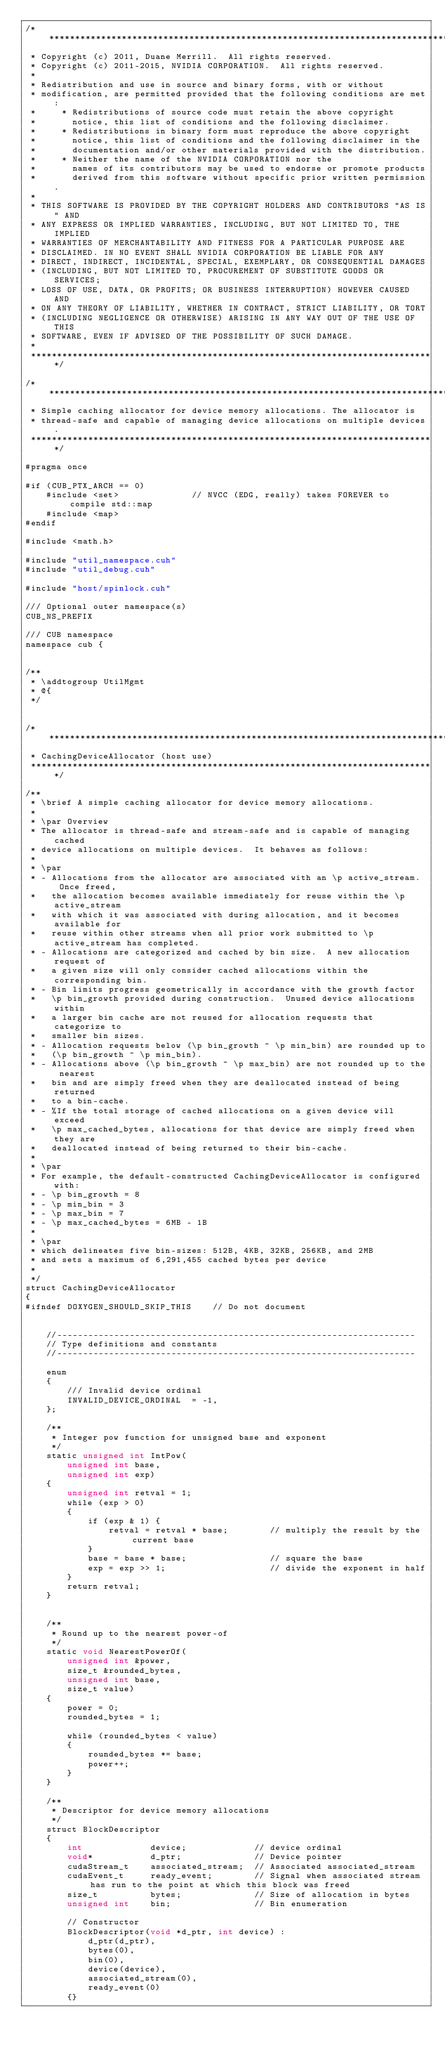Convert code to text. <code><loc_0><loc_0><loc_500><loc_500><_Cuda_>/******************************************************************************
 * Copyright (c) 2011, Duane Merrill.  All rights reserved.
 * Copyright (c) 2011-2015, NVIDIA CORPORATION.  All rights reserved.
 *
 * Redistribution and use in source and binary forms, with or without
 * modification, are permitted provided that the following conditions are met:
 *     * Redistributions of source code must retain the above copyright
 *       notice, this list of conditions and the following disclaimer.
 *     * Redistributions in binary form must reproduce the above copyright
 *       notice, this list of conditions and the following disclaimer in the
 *       documentation and/or other materials provided with the distribution.
 *     * Neither the name of the NVIDIA CORPORATION nor the
 *       names of its contributors may be used to endorse or promote products
 *       derived from this software without specific prior written permission.
 *
 * THIS SOFTWARE IS PROVIDED BY THE COPYRIGHT HOLDERS AND CONTRIBUTORS "AS IS" AND
 * ANY EXPRESS OR IMPLIED WARRANTIES, INCLUDING, BUT NOT LIMITED TO, THE IMPLIED
 * WARRANTIES OF MERCHANTABILITY AND FITNESS FOR A PARTICULAR PURPOSE ARE
 * DISCLAIMED. IN NO EVENT SHALL NVIDIA CORPORATION BE LIABLE FOR ANY
 * DIRECT, INDIRECT, INCIDENTAL, SPECIAL, EXEMPLARY, OR CONSEQUENTIAL DAMAGES
 * (INCLUDING, BUT NOT LIMITED TO, PROCUREMENT OF SUBSTITUTE GOODS OR SERVICES;
 * LOSS OF USE, DATA, OR PROFITS; OR BUSINESS INTERRUPTION) HOWEVER CAUSED AND
 * ON ANY THEORY OF LIABILITY, WHETHER IN CONTRACT, STRICT LIABILITY, OR TORT
 * (INCLUDING NEGLIGENCE OR OTHERWISE) ARISING IN ANY WAY OUT OF THE USE OF THIS
 * SOFTWARE, EVEN IF ADVISED OF THE POSSIBILITY OF SUCH DAMAGE.
 *
 ******************************************************************************/

/******************************************************************************
 * Simple caching allocator for device memory allocations. The allocator is
 * thread-safe and capable of managing device allocations on multiple devices.
 ******************************************************************************/

#pragma once

#if (CUB_PTX_ARCH == 0)
    #include <set>              // NVCC (EDG, really) takes FOREVER to compile std::map
    #include <map>
#endif

#include <math.h>

#include "util_namespace.cuh"
#include "util_debug.cuh"

#include "host/spinlock.cuh"

/// Optional outer namespace(s)
CUB_NS_PREFIX

/// CUB namespace
namespace cub {


/**
 * \addtogroup UtilMgmt
 * @{
 */


/******************************************************************************
 * CachingDeviceAllocator (host use)
 ******************************************************************************/

/**
 * \brief A simple caching allocator for device memory allocations.
 *
 * \par Overview
 * The allocator is thread-safe and stream-safe and is capable of managing cached
 * device allocations on multiple devices.  It behaves as follows:
 *
 * \par
 * - Allocations from the allocator are associated with an \p active_stream.  Once freed,
 *   the allocation becomes available immediately for reuse within the \p active_stream
 *   with which it was associated with during allocation, and it becomes available for
 *   reuse within other streams when all prior work submitted to \p active_stream has completed.
 * - Allocations are categorized and cached by bin size.  A new allocation request of
 *   a given size will only consider cached allocations within the corresponding bin.
 * - Bin limits progress geometrically in accordance with the growth factor
 *   \p bin_growth provided during construction.  Unused device allocations within
 *   a larger bin cache are not reused for allocation requests that categorize to
 *   smaller bin sizes.
 * - Allocation requests below (\p bin_growth ^ \p min_bin) are rounded up to
 *   (\p bin_growth ^ \p min_bin).
 * - Allocations above (\p bin_growth ^ \p max_bin) are not rounded up to the nearest
 *   bin and are simply freed when they are deallocated instead of being returned
 *   to a bin-cache.
 * - %If the total storage of cached allocations on a given device will exceed
 *   \p max_cached_bytes, allocations for that device are simply freed when they are
 *   deallocated instead of being returned to their bin-cache.
 *
 * \par
 * For example, the default-constructed CachingDeviceAllocator is configured with:
 * - \p bin_growth = 8
 * - \p min_bin = 3
 * - \p max_bin = 7
 * - \p max_cached_bytes = 6MB - 1B
 *
 * \par
 * which delineates five bin-sizes: 512B, 4KB, 32KB, 256KB, and 2MB
 * and sets a maximum of 6,291,455 cached bytes per device
 *
 */
struct CachingDeviceAllocator
{
#ifndef DOXYGEN_SHOULD_SKIP_THIS    // Do not document


    //---------------------------------------------------------------------
    // Type definitions and constants
    //---------------------------------------------------------------------

    enum
    {
        /// Invalid device ordinal
        INVALID_DEVICE_ORDINAL  = -1,
    };

    /**
     * Integer pow function for unsigned base and exponent
     */
    static unsigned int IntPow(
        unsigned int base,
        unsigned int exp)
    {
        unsigned int retval = 1;
        while (exp > 0)
        {
            if (exp & 1) {
                retval = retval * base;        // multiply the result by the current base
            }
            base = base * base;                // square the base
            exp = exp >> 1;                    // divide the exponent in half
        }
        return retval;
    }


    /**
     * Round up to the nearest power-of
     */
    static void NearestPowerOf(
        unsigned int &power,
        size_t &rounded_bytes,
        unsigned int base,
        size_t value)
    {
        power = 0;
        rounded_bytes = 1;

        while (rounded_bytes < value)
        {
            rounded_bytes *= base;
            power++;
        }
    }

    /**
     * Descriptor for device memory allocations
     */
    struct BlockDescriptor
    {
        int             device;             // device ordinal
        void*           d_ptr;              // Device pointer
        cudaStream_t    associated_stream;  // Associated associated_stream
        cudaEvent_t     ready_event;        // Signal when associated stream has run to the point at which this block was freed
        size_t          bytes;              // Size of allocation in bytes
        unsigned int    bin;                // Bin enumeration

        // Constructor
        BlockDescriptor(void *d_ptr, int device) :
            d_ptr(d_ptr),
            bytes(0),
            bin(0),
            device(device),
            associated_stream(0),
            ready_event(0)
        {}
</code> 